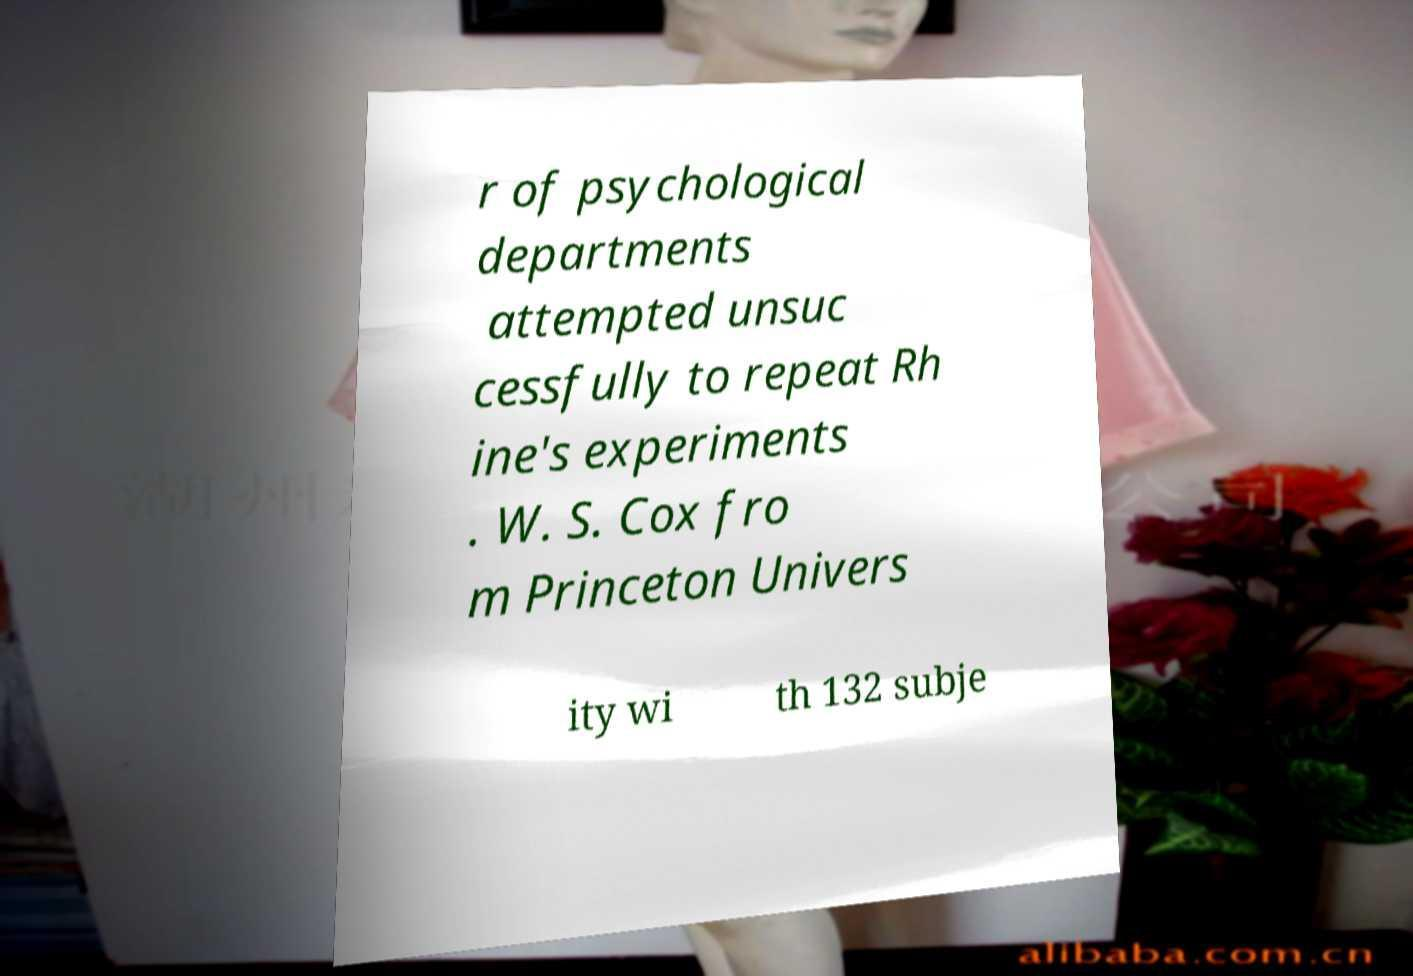For documentation purposes, I need the text within this image transcribed. Could you provide that? r of psychological departments attempted unsuc cessfully to repeat Rh ine's experiments . W. S. Cox fro m Princeton Univers ity wi th 132 subje 